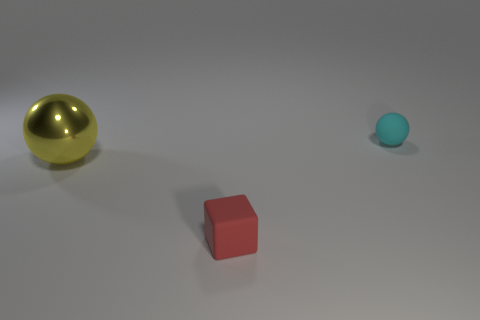Add 3 tiny blocks. How many objects exist? 6 Subtract all spheres. How many objects are left? 1 Add 1 small cyan rubber spheres. How many small cyan rubber spheres are left? 2 Add 1 cyan rubber objects. How many cyan rubber objects exist? 2 Subtract 0 purple blocks. How many objects are left? 3 Subtract all tiny blue shiny spheres. Subtract all rubber cubes. How many objects are left? 2 